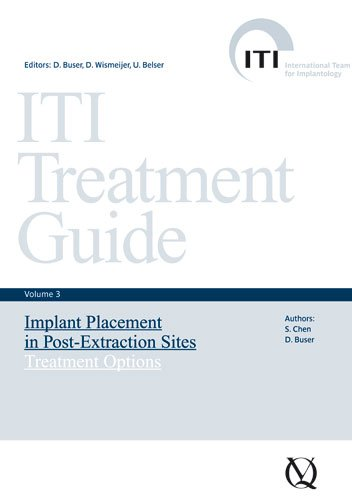What type of book is this? This is a specialized medical text focusing on dental procedures, particularly implant placements following tooth extractions, intended for professionals in dental surgery and implantology. 